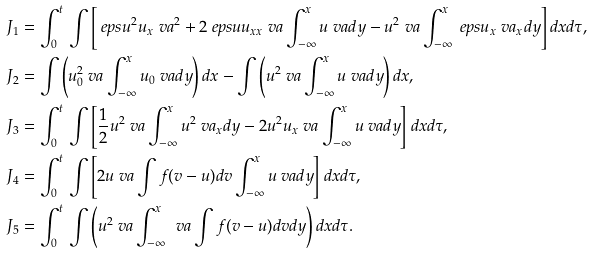Convert formula to latex. <formula><loc_0><loc_0><loc_500><loc_500>J _ { 1 } & = \int _ { 0 } ^ { t } \, \int \left [ \ e p s u ^ { 2 } u _ { x } \ v a ^ { 2 } + 2 \ e p s u u _ { x x } \ v a \int _ { - \infty } ^ { x } u \ v a d y - u ^ { 2 } \ v a \int _ { - \infty } ^ { x } \ e p s u _ { x } \ v a _ { x } d y \right ] d x d \tau , \\ J _ { 2 } & = \int \left ( u _ { 0 } ^ { 2 } \ v a \int _ { - \infty } ^ { x } u _ { 0 } \ v a d y \right ) d x - \int \left ( u ^ { 2 } \ v a \int _ { - \infty } ^ { x } u \ v a d y \right ) d x , \\ J _ { 3 } & = \int _ { 0 } ^ { t } \, \int \left [ \frac { 1 } { 2 } u ^ { 2 } \ v a \int _ { - \infty } ^ { x } u ^ { 2 } \ v a _ { x } d y - 2 u ^ { 2 } u _ { x } \ v a \int _ { - \infty } ^ { x } u \ v a d y \right ] d x d \tau , \\ J _ { 4 } & = \int _ { 0 } ^ { t } \, \int \left [ 2 u \ v a \int f ( v - u ) d v \int _ { - \infty } ^ { x } u \ v a d y \right ] d x d \tau , \\ J _ { 5 } & = \int _ { 0 } ^ { t } \, \int \left ( u ^ { 2 } \ v a \int _ { - \infty } ^ { x } \, \ v a \int f ( v - u ) d v d y \right ) d x d \tau .</formula> 